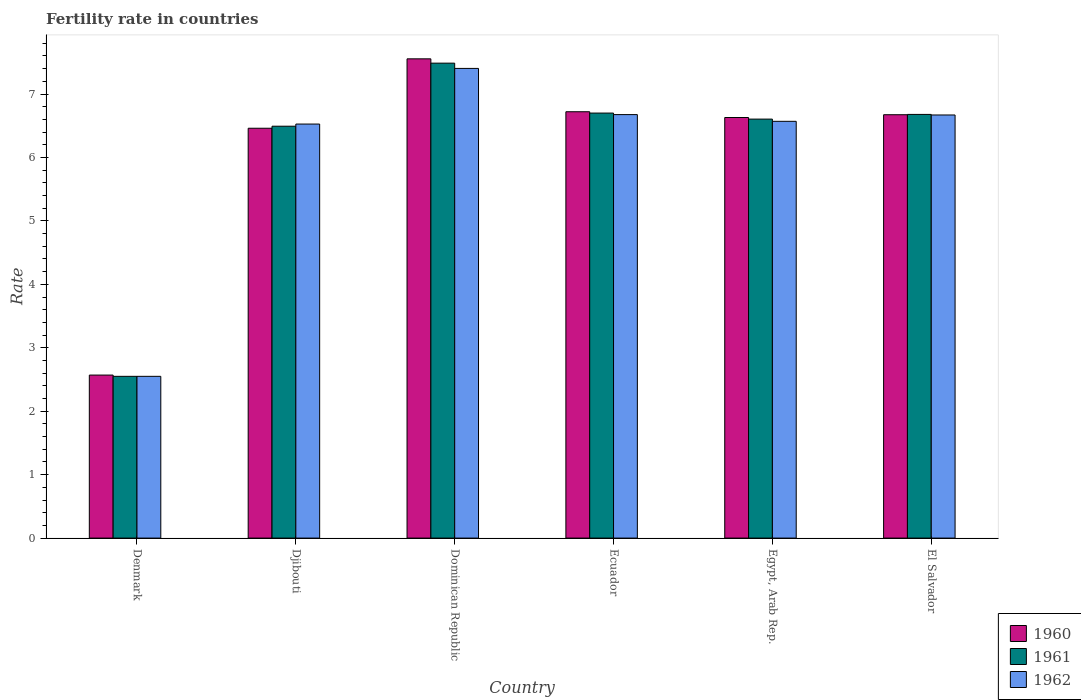Are the number of bars per tick equal to the number of legend labels?
Provide a succinct answer. Yes. Are the number of bars on each tick of the X-axis equal?
Give a very brief answer. Yes. How many bars are there on the 2nd tick from the left?
Your answer should be very brief. 3. What is the fertility rate in 1960 in Ecuador?
Offer a very short reply. 6.72. Across all countries, what is the maximum fertility rate in 1961?
Your answer should be very brief. 7.49. Across all countries, what is the minimum fertility rate in 1961?
Keep it short and to the point. 2.55. In which country was the fertility rate in 1960 maximum?
Your answer should be very brief. Dominican Republic. In which country was the fertility rate in 1962 minimum?
Keep it short and to the point. Denmark. What is the total fertility rate in 1962 in the graph?
Provide a short and direct response. 36.4. What is the difference between the fertility rate in 1962 in Dominican Republic and that in Ecuador?
Provide a short and direct response. 0.73. What is the difference between the fertility rate in 1960 in Denmark and the fertility rate in 1961 in Ecuador?
Give a very brief answer. -4.13. What is the average fertility rate in 1962 per country?
Provide a succinct answer. 6.07. What is the difference between the fertility rate of/in 1961 and fertility rate of/in 1962 in Djibouti?
Provide a succinct answer. -0.03. In how many countries, is the fertility rate in 1962 greater than 3.6?
Your response must be concise. 5. What is the ratio of the fertility rate in 1962 in Djibouti to that in El Salvador?
Give a very brief answer. 0.98. What is the difference between the highest and the second highest fertility rate in 1962?
Offer a terse response. -0.01. What is the difference between the highest and the lowest fertility rate in 1960?
Your answer should be compact. 4.98. In how many countries, is the fertility rate in 1960 greater than the average fertility rate in 1960 taken over all countries?
Your answer should be very brief. 5. What does the 1st bar from the left in Egypt, Arab Rep. represents?
Provide a succinct answer. 1960. Is it the case that in every country, the sum of the fertility rate in 1961 and fertility rate in 1960 is greater than the fertility rate in 1962?
Your response must be concise. Yes. How many bars are there?
Your response must be concise. 18. Are all the bars in the graph horizontal?
Offer a terse response. No. How many countries are there in the graph?
Offer a very short reply. 6. What is the difference between two consecutive major ticks on the Y-axis?
Your response must be concise. 1. Are the values on the major ticks of Y-axis written in scientific E-notation?
Offer a terse response. No. Does the graph contain any zero values?
Keep it short and to the point. No. Where does the legend appear in the graph?
Your response must be concise. Bottom right. What is the title of the graph?
Offer a terse response. Fertility rate in countries. Does "1967" appear as one of the legend labels in the graph?
Ensure brevity in your answer.  No. What is the label or title of the Y-axis?
Keep it short and to the point. Rate. What is the Rate in 1960 in Denmark?
Your answer should be compact. 2.57. What is the Rate in 1961 in Denmark?
Offer a terse response. 2.55. What is the Rate of 1962 in Denmark?
Your response must be concise. 2.55. What is the Rate of 1960 in Djibouti?
Provide a succinct answer. 6.46. What is the Rate of 1961 in Djibouti?
Your answer should be compact. 6.49. What is the Rate of 1962 in Djibouti?
Provide a short and direct response. 6.53. What is the Rate in 1960 in Dominican Republic?
Your answer should be compact. 7.55. What is the Rate in 1961 in Dominican Republic?
Your response must be concise. 7.49. What is the Rate in 1962 in Dominican Republic?
Provide a short and direct response. 7.4. What is the Rate of 1960 in Ecuador?
Ensure brevity in your answer.  6.72. What is the Rate of 1962 in Ecuador?
Offer a terse response. 6.68. What is the Rate in 1960 in Egypt, Arab Rep.?
Make the answer very short. 6.63. What is the Rate of 1961 in Egypt, Arab Rep.?
Keep it short and to the point. 6.61. What is the Rate in 1962 in Egypt, Arab Rep.?
Keep it short and to the point. 6.57. What is the Rate of 1960 in El Salvador?
Offer a very short reply. 6.67. What is the Rate of 1961 in El Salvador?
Give a very brief answer. 6.68. What is the Rate of 1962 in El Salvador?
Give a very brief answer. 6.67. Across all countries, what is the maximum Rate of 1960?
Offer a very short reply. 7.55. Across all countries, what is the maximum Rate of 1961?
Give a very brief answer. 7.49. Across all countries, what is the maximum Rate in 1962?
Your answer should be compact. 7.4. Across all countries, what is the minimum Rate of 1960?
Ensure brevity in your answer.  2.57. Across all countries, what is the minimum Rate in 1961?
Offer a terse response. 2.55. Across all countries, what is the minimum Rate in 1962?
Provide a succinct answer. 2.55. What is the total Rate in 1960 in the graph?
Provide a short and direct response. 36.61. What is the total Rate of 1961 in the graph?
Ensure brevity in your answer.  36.51. What is the total Rate in 1962 in the graph?
Your response must be concise. 36.4. What is the difference between the Rate of 1960 in Denmark and that in Djibouti?
Your response must be concise. -3.89. What is the difference between the Rate of 1961 in Denmark and that in Djibouti?
Keep it short and to the point. -3.94. What is the difference between the Rate in 1962 in Denmark and that in Djibouti?
Provide a short and direct response. -3.98. What is the difference between the Rate of 1960 in Denmark and that in Dominican Republic?
Your answer should be very brief. -4.99. What is the difference between the Rate in 1961 in Denmark and that in Dominican Republic?
Provide a short and direct response. -4.94. What is the difference between the Rate in 1962 in Denmark and that in Dominican Republic?
Your response must be concise. -4.85. What is the difference between the Rate of 1960 in Denmark and that in Ecuador?
Ensure brevity in your answer.  -4.15. What is the difference between the Rate in 1961 in Denmark and that in Ecuador?
Provide a succinct answer. -4.15. What is the difference between the Rate of 1962 in Denmark and that in Ecuador?
Make the answer very short. -4.13. What is the difference between the Rate in 1960 in Denmark and that in Egypt, Arab Rep.?
Provide a short and direct response. -4.06. What is the difference between the Rate in 1961 in Denmark and that in Egypt, Arab Rep.?
Provide a short and direct response. -4.05. What is the difference between the Rate in 1962 in Denmark and that in Egypt, Arab Rep.?
Your response must be concise. -4.02. What is the difference between the Rate of 1960 in Denmark and that in El Salvador?
Provide a succinct answer. -4.1. What is the difference between the Rate in 1961 in Denmark and that in El Salvador?
Give a very brief answer. -4.13. What is the difference between the Rate of 1962 in Denmark and that in El Salvador?
Your response must be concise. -4.12. What is the difference between the Rate in 1960 in Djibouti and that in Dominican Republic?
Provide a succinct answer. -1.09. What is the difference between the Rate in 1961 in Djibouti and that in Dominican Republic?
Your answer should be very brief. -0.99. What is the difference between the Rate of 1962 in Djibouti and that in Dominican Republic?
Make the answer very short. -0.88. What is the difference between the Rate in 1960 in Djibouti and that in Ecuador?
Your response must be concise. -0.26. What is the difference between the Rate of 1961 in Djibouti and that in Ecuador?
Make the answer very short. -0.21. What is the difference between the Rate in 1962 in Djibouti and that in Ecuador?
Give a very brief answer. -0.15. What is the difference between the Rate in 1960 in Djibouti and that in Egypt, Arab Rep.?
Your answer should be compact. -0.17. What is the difference between the Rate in 1961 in Djibouti and that in Egypt, Arab Rep.?
Provide a succinct answer. -0.11. What is the difference between the Rate of 1962 in Djibouti and that in Egypt, Arab Rep.?
Offer a terse response. -0.04. What is the difference between the Rate in 1960 in Djibouti and that in El Salvador?
Ensure brevity in your answer.  -0.21. What is the difference between the Rate in 1961 in Djibouti and that in El Salvador?
Offer a very short reply. -0.19. What is the difference between the Rate in 1962 in Djibouti and that in El Salvador?
Offer a very short reply. -0.14. What is the difference between the Rate in 1960 in Dominican Republic and that in Ecuador?
Provide a succinct answer. 0.83. What is the difference between the Rate of 1961 in Dominican Republic and that in Ecuador?
Give a very brief answer. 0.79. What is the difference between the Rate of 1962 in Dominican Republic and that in Ecuador?
Your answer should be very brief. 0.73. What is the difference between the Rate in 1960 in Dominican Republic and that in Egypt, Arab Rep.?
Ensure brevity in your answer.  0.93. What is the difference between the Rate of 1961 in Dominican Republic and that in Egypt, Arab Rep.?
Keep it short and to the point. 0.88. What is the difference between the Rate of 1962 in Dominican Republic and that in Egypt, Arab Rep.?
Make the answer very short. 0.83. What is the difference between the Rate in 1960 in Dominican Republic and that in El Salvador?
Your response must be concise. 0.88. What is the difference between the Rate in 1961 in Dominican Republic and that in El Salvador?
Provide a short and direct response. 0.81. What is the difference between the Rate of 1962 in Dominican Republic and that in El Salvador?
Give a very brief answer. 0.73. What is the difference between the Rate in 1960 in Ecuador and that in Egypt, Arab Rep.?
Make the answer very short. 0.09. What is the difference between the Rate of 1961 in Ecuador and that in Egypt, Arab Rep.?
Your answer should be very brief. 0.1. What is the difference between the Rate in 1962 in Ecuador and that in Egypt, Arab Rep.?
Offer a very short reply. 0.11. What is the difference between the Rate in 1960 in Ecuador and that in El Salvador?
Keep it short and to the point. 0.05. What is the difference between the Rate of 1961 in Ecuador and that in El Salvador?
Offer a very short reply. 0.02. What is the difference between the Rate in 1962 in Ecuador and that in El Salvador?
Offer a very short reply. 0.01. What is the difference between the Rate in 1960 in Egypt, Arab Rep. and that in El Salvador?
Give a very brief answer. -0.04. What is the difference between the Rate of 1961 in Egypt, Arab Rep. and that in El Salvador?
Make the answer very short. -0.07. What is the difference between the Rate of 1962 in Egypt, Arab Rep. and that in El Salvador?
Your answer should be compact. -0.1. What is the difference between the Rate of 1960 in Denmark and the Rate of 1961 in Djibouti?
Provide a succinct answer. -3.92. What is the difference between the Rate of 1960 in Denmark and the Rate of 1962 in Djibouti?
Ensure brevity in your answer.  -3.96. What is the difference between the Rate in 1961 in Denmark and the Rate in 1962 in Djibouti?
Offer a terse response. -3.98. What is the difference between the Rate in 1960 in Denmark and the Rate in 1961 in Dominican Republic?
Ensure brevity in your answer.  -4.92. What is the difference between the Rate of 1960 in Denmark and the Rate of 1962 in Dominican Republic?
Offer a very short reply. -4.83. What is the difference between the Rate in 1961 in Denmark and the Rate in 1962 in Dominican Republic?
Provide a succinct answer. -4.85. What is the difference between the Rate of 1960 in Denmark and the Rate of 1961 in Ecuador?
Offer a very short reply. -4.13. What is the difference between the Rate of 1960 in Denmark and the Rate of 1962 in Ecuador?
Your answer should be very brief. -4.11. What is the difference between the Rate of 1961 in Denmark and the Rate of 1962 in Ecuador?
Ensure brevity in your answer.  -4.13. What is the difference between the Rate in 1960 in Denmark and the Rate in 1961 in Egypt, Arab Rep.?
Offer a very short reply. -4.04. What is the difference between the Rate in 1961 in Denmark and the Rate in 1962 in Egypt, Arab Rep.?
Offer a very short reply. -4.02. What is the difference between the Rate of 1960 in Denmark and the Rate of 1961 in El Salvador?
Your answer should be compact. -4.11. What is the difference between the Rate of 1961 in Denmark and the Rate of 1962 in El Salvador?
Offer a very short reply. -4.12. What is the difference between the Rate of 1960 in Djibouti and the Rate of 1961 in Dominican Republic?
Give a very brief answer. -1.03. What is the difference between the Rate of 1960 in Djibouti and the Rate of 1962 in Dominican Republic?
Make the answer very short. -0.94. What is the difference between the Rate of 1961 in Djibouti and the Rate of 1962 in Dominican Republic?
Keep it short and to the point. -0.91. What is the difference between the Rate of 1960 in Djibouti and the Rate of 1961 in Ecuador?
Ensure brevity in your answer.  -0.24. What is the difference between the Rate of 1960 in Djibouti and the Rate of 1962 in Ecuador?
Offer a terse response. -0.21. What is the difference between the Rate in 1961 in Djibouti and the Rate in 1962 in Ecuador?
Provide a short and direct response. -0.18. What is the difference between the Rate in 1960 in Djibouti and the Rate in 1961 in Egypt, Arab Rep.?
Your answer should be compact. -0.14. What is the difference between the Rate of 1960 in Djibouti and the Rate of 1962 in Egypt, Arab Rep.?
Your answer should be very brief. -0.11. What is the difference between the Rate in 1961 in Djibouti and the Rate in 1962 in Egypt, Arab Rep.?
Your response must be concise. -0.08. What is the difference between the Rate in 1960 in Djibouti and the Rate in 1961 in El Salvador?
Provide a short and direct response. -0.22. What is the difference between the Rate of 1960 in Djibouti and the Rate of 1962 in El Salvador?
Offer a terse response. -0.21. What is the difference between the Rate in 1961 in Djibouti and the Rate in 1962 in El Salvador?
Your answer should be compact. -0.18. What is the difference between the Rate in 1960 in Dominican Republic and the Rate in 1961 in Ecuador?
Provide a short and direct response. 0.85. What is the difference between the Rate of 1960 in Dominican Republic and the Rate of 1962 in Ecuador?
Make the answer very short. 0.88. What is the difference between the Rate of 1961 in Dominican Republic and the Rate of 1962 in Ecuador?
Offer a very short reply. 0.81. What is the difference between the Rate of 1961 in Dominican Republic and the Rate of 1962 in Egypt, Arab Rep.?
Your response must be concise. 0.92. What is the difference between the Rate of 1960 in Dominican Republic and the Rate of 1961 in El Salvador?
Your answer should be very brief. 0.88. What is the difference between the Rate of 1960 in Dominican Republic and the Rate of 1962 in El Salvador?
Provide a short and direct response. 0.89. What is the difference between the Rate of 1961 in Dominican Republic and the Rate of 1962 in El Salvador?
Ensure brevity in your answer.  0.82. What is the difference between the Rate of 1960 in Ecuador and the Rate of 1961 in Egypt, Arab Rep.?
Your response must be concise. 0.12. What is the difference between the Rate in 1960 in Ecuador and the Rate in 1962 in Egypt, Arab Rep.?
Your answer should be very brief. 0.15. What is the difference between the Rate in 1961 in Ecuador and the Rate in 1962 in Egypt, Arab Rep.?
Your answer should be very brief. 0.13. What is the difference between the Rate of 1960 in Ecuador and the Rate of 1961 in El Salvador?
Provide a succinct answer. 0.04. What is the difference between the Rate of 1960 in Ecuador and the Rate of 1962 in El Salvador?
Provide a succinct answer. 0.05. What is the difference between the Rate in 1961 in Ecuador and the Rate in 1962 in El Salvador?
Your response must be concise. 0.03. What is the difference between the Rate in 1960 in Egypt, Arab Rep. and the Rate in 1961 in El Salvador?
Ensure brevity in your answer.  -0.05. What is the difference between the Rate in 1960 in Egypt, Arab Rep. and the Rate in 1962 in El Salvador?
Your answer should be compact. -0.04. What is the difference between the Rate in 1961 in Egypt, Arab Rep. and the Rate in 1962 in El Salvador?
Give a very brief answer. -0.07. What is the average Rate of 1960 per country?
Provide a succinct answer. 6.1. What is the average Rate of 1961 per country?
Your response must be concise. 6.09. What is the average Rate in 1962 per country?
Make the answer very short. 6.07. What is the difference between the Rate of 1961 and Rate of 1962 in Denmark?
Provide a succinct answer. 0. What is the difference between the Rate in 1960 and Rate in 1961 in Djibouti?
Your answer should be compact. -0.03. What is the difference between the Rate of 1960 and Rate of 1962 in Djibouti?
Ensure brevity in your answer.  -0.07. What is the difference between the Rate of 1961 and Rate of 1962 in Djibouti?
Make the answer very short. -0.03. What is the difference between the Rate in 1960 and Rate in 1961 in Dominican Republic?
Your response must be concise. 0.07. What is the difference between the Rate in 1960 and Rate in 1962 in Dominican Republic?
Keep it short and to the point. 0.15. What is the difference between the Rate in 1961 and Rate in 1962 in Dominican Republic?
Ensure brevity in your answer.  0.08. What is the difference between the Rate in 1960 and Rate in 1961 in Ecuador?
Offer a very short reply. 0.02. What is the difference between the Rate in 1960 and Rate in 1962 in Ecuador?
Make the answer very short. 0.04. What is the difference between the Rate of 1961 and Rate of 1962 in Ecuador?
Offer a terse response. 0.02. What is the difference between the Rate of 1960 and Rate of 1961 in Egypt, Arab Rep.?
Ensure brevity in your answer.  0.03. What is the difference between the Rate in 1960 and Rate in 1962 in Egypt, Arab Rep.?
Provide a succinct answer. 0.06. What is the difference between the Rate of 1961 and Rate of 1962 in Egypt, Arab Rep.?
Give a very brief answer. 0.04. What is the difference between the Rate in 1960 and Rate in 1961 in El Salvador?
Make the answer very short. -0.01. What is the difference between the Rate of 1960 and Rate of 1962 in El Salvador?
Your answer should be compact. 0. What is the difference between the Rate of 1961 and Rate of 1962 in El Salvador?
Provide a short and direct response. 0.01. What is the ratio of the Rate of 1960 in Denmark to that in Djibouti?
Provide a short and direct response. 0.4. What is the ratio of the Rate of 1961 in Denmark to that in Djibouti?
Your answer should be compact. 0.39. What is the ratio of the Rate in 1962 in Denmark to that in Djibouti?
Your answer should be very brief. 0.39. What is the ratio of the Rate in 1960 in Denmark to that in Dominican Republic?
Make the answer very short. 0.34. What is the ratio of the Rate of 1961 in Denmark to that in Dominican Republic?
Provide a succinct answer. 0.34. What is the ratio of the Rate in 1962 in Denmark to that in Dominican Republic?
Keep it short and to the point. 0.34. What is the ratio of the Rate of 1960 in Denmark to that in Ecuador?
Keep it short and to the point. 0.38. What is the ratio of the Rate of 1961 in Denmark to that in Ecuador?
Offer a very short reply. 0.38. What is the ratio of the Rate in 1962 in Denmark to that in Ecuador?
Your answer should be very brief. 0.38. What is the ratio of the Rate in 1960 in Denmark to that in Egypt, Arab Rep.?
Your response must be concise. 0.39. What is the ratio of the Rate in 1961 in Denmark to that in Egypt, Arab Rep.?
Offer a very short reply. 0.39. What is the ratio of the Rate in 1962 in Denmark to that in Egypt, Arab Rep.?
Ensure brevity in your answer.  0.39. What is the ratio of the Rate in 1960 in Denmark to that in El Salvador?
Keep it short and to the point. 0.39. What is the ratio of the Rate in 1961 in Denmark to that in El Salvador?
Make the answer very short. 0.38. What is the ratio of the Rate in 1962 in Denmark to that in El Salvador?
Give a very brief answer. 0.38. What is the ratio of the Rate in 1960 in Djibouti to that in Dominican Republic?
Give a very brief answer. 0.86. What is the ratio of the Rate in 1961 in Djibouti to that in Dominican Republic?
Your answer should be compact. 0.87. What is the ratio of the Rate in 1962 in Djibouti to that in Dominican Republic?
Give a very brief answer. 0.88. What is the ratio of the Rate in 1960 in Djibouti to that in Ecuador?
Your response must be concise. 0.96. What is the ratio of the Rate in 1961 in Djibouti to that in Ecuador?
Your answer should be compact. 0.97. What is the ratio of the Rate of 1962 in Djibouti to that in Ecuador?
Ensure brevity in your answer.  0.98. What is the ratio of the Rate of 1960 in Djibouti to that in Egypt, Arab Rep.?
Your answer should be very brief. 0.97. What is the ratio of the Rate of 1961 in Djibouti to that in Egypt, Arab Rep.?
Offer a very short reply. 0.98. What is the ratio of the Rate in 1962 in Djibouti to that in Egypt, Arab Rep.?
Ensure brevity in your answer.  0.99. What is the ratio of the Rate of 1960 in Djibouti to that in El Salvador?
Provide a short and direct response. 0.97. What is the ratio of the Rate of 1961 in Djibouti to that in El Salvador?
Ensure brevity in your answer.  0.97. What is the ratio of the Rate of 1962 in Djibouti to that in El Salvador?
Give a very brief answer. 0.98. What is the ratio of the Rate of 1960 in Dominican Republic to that in Ecuador?
Offer a very short reply. 1.12. What is the ratio of the Rate in 1961 in Dominican Republic to that in Ecuador?
Your answer should be compact. 1.12. What is the ratio of the Rate of 1962 in Dominican Republic to that in Ecuador?
Offer a very short reply. 1.11. What is the ratio of the Rate in 1960 in Dominican Republic to that in Egypt, Arab Rep.?
Make the answer very short. 1.14. What is the ratio of the Rate in 1961 in Dominican Republic to that in Egypt, Arab Rep.?
Offer a very short reply. 1.13. What is the ratio of the Rate in 1962 in Dominican Republic to that in Egypt, Arab Rep.?
Provide a succinct answer. 1.13. What is the ratio of the Rate in 1960 in Dominican Republic to that in El Salvador?
Ensure brevity in your answer.  1.13. What is the ratio of the Rate in 1961 in Dominican Republic to that in El Salvador?
Your response must be concise. 1.12. What is the ratio of the Rate of 1962 in Dominican Republic to that in El Salvador?
Offer a very short reply. 1.11. What is the ratio of the Rate of 1960 in Ecuador to that in Egypt, Arab Rep.?
Your answer should be compact. 1.01. What is the ratio of the Rate of 1961 in Ecuador to that in Egypt, Arab Rep.?
Keep it short and to the point. 1.01. What is the ratio of the Rate in 1962 in Ecuador to that in Egypt, Arab Rep.?
Offer a terse response. 1.02. What is the ratio of the Rate of 1961 in Ecuador to that in El Salvador?
Your answer should be very brief. 1. What is the ratio of the Rate of 1962 in Ecuador to that in El Salvador?
Make the answer very short. 1. What is the ratio of the Rate in 1960 in Egypt, Arab Rep. to that in El Salvador?
Ensure brevity in your answer.  0.99. What is the ratio of the Rate of 1961 in Egypt, Arab Rep. to that in El Salvador?
Keep it short and to the point. 0.99. What is the ratio of the Rate in 1962 in Egypt, Arab Rep. to that in El Salvador?
Ensure brevity in your answer.  0.98. What is the difference between the highest and the second highest Rate of 1960?
Your answer should be very brief. 0.83. What is the difference between the highest and the second highest Rate in 1961?
Offer a very short reply. 0.79. What is the difference between the highest and the second highest Rate of 1962?
Keep it short and to the point. 0.73. What is the difference between the highest and the lowest Rate in 1960?
Provide a succinct answer. 4.99. What is the difference between the highest and the lowest Rate of 1961?
Give a very brief answer. 4.94. What is the difference between the highest and the lowest Rate in 1962?
Provide a succinct answer. 4.85. 